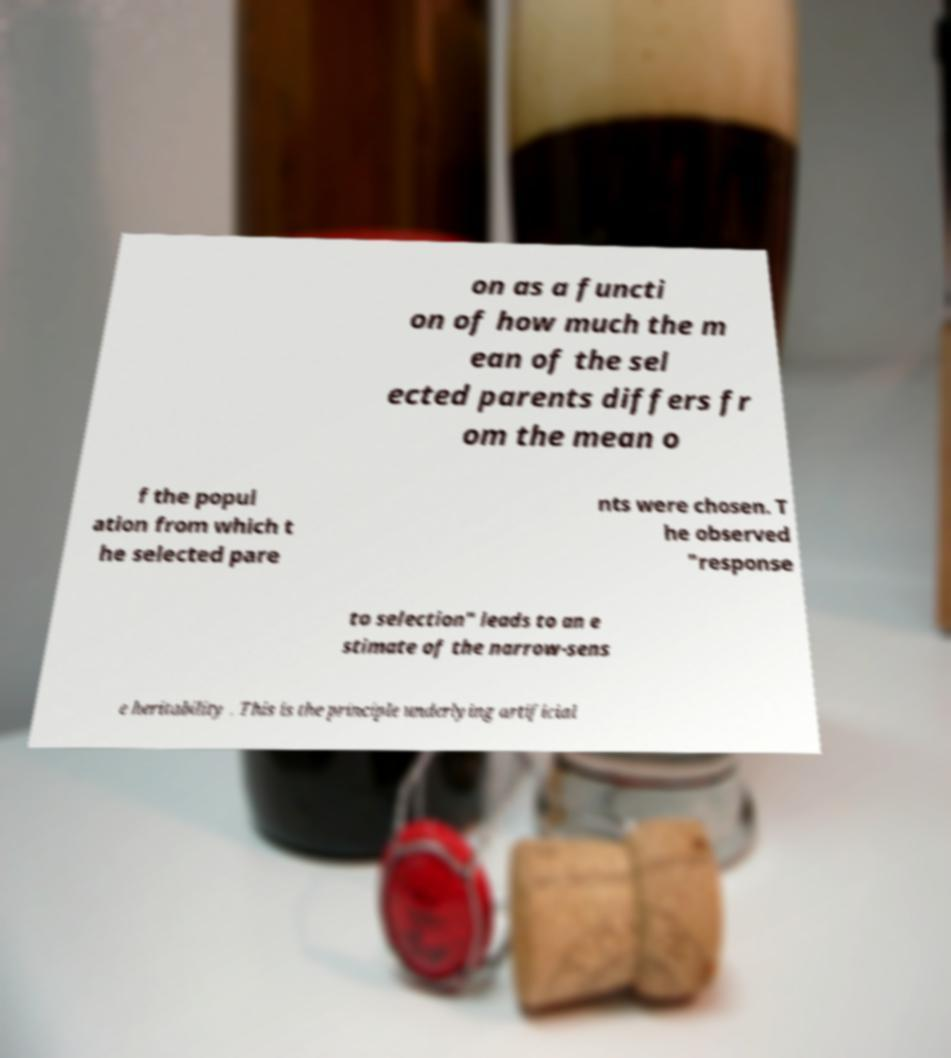Could you extract and type out the text from this image? on as a functi on of how much the m ean of the sel ected parents differs fr om the mean o f the popul ation from which t he selected pare nts were chosen. T he observed "response to selection" leads to an e stimate of the narrow-sens e heritability . This is the principle underlying artificial 